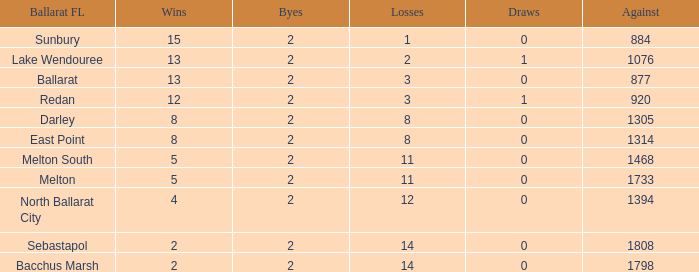How many byes are in opposition to 1076 and possess wins less than 13? None. 